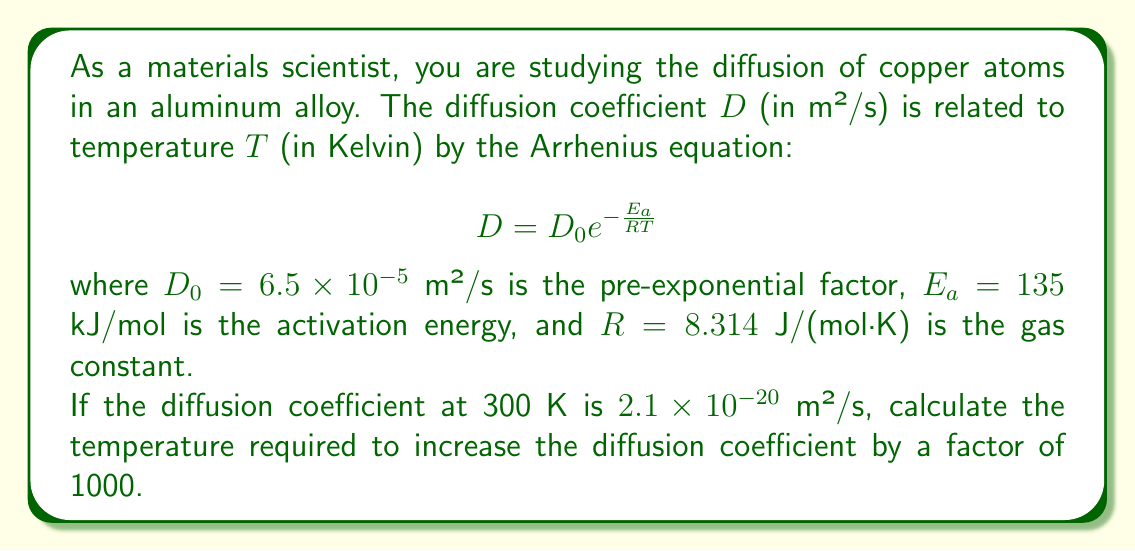Show me your answer to this math problem. To solve this problem, we'll follow these steps:

1) First, let's write the equation for the initial diffusion coefficient at 300 K:

   $$2.1 \times 10^{-20} = 6.5 \times 10^{-5} e^{-\frac{135000}{8.314 \times 300}}$$

2) Now, let's write the equation for the new diffusion coefficient at temperature $T$, which is 1000 times larger:

   $$2.1 \times 10^{-17} = 6.5 \times 10^{-5} e^{-\frac{135000}{8.314 \times T}}$$

3) Dividing the second equation by the first:

   $$\frac{2.1 \times 10^{-17}}{2.1 \times 10^{-20}} = \frac{e^{-\frac{135000}{8.314 \times T}}}{e^{-\frac{135000}{8.314 \times 300}}}$$

4) Simplify:

   $$1000 = e^{\frac{135000}{8.314}(\frac{1}{300} - \frac{1}{T})}$$

5) Take the natural logarithm of both sides:

   $$\ln(1000) = \frac{135000}{8.314}(\frac{1}{300} - \frac{1}{T})$$

6) Solve for $\frac{1}{T}$:

   $$\frac{1}{T} = \frac{1}{300} - \frac{8.314 \times \ln(1000)}{135000}$$

7) Calculate:

   $$\frac{1}{T} = \frac{1}{300} - \frac{8.314 \times 6.908}{135000} = 0.00333 - 0.00042 = 0.00291$$

8) Finally, take the reciprocal to find $T$:

   $$T = \frac{1}{0.00291} = 343.6 \text{ K}$$
Answer: The temperature required to increase the diffusion coefficient by a factor of 1000 is approximately 343.6 K or 70.6°C. 